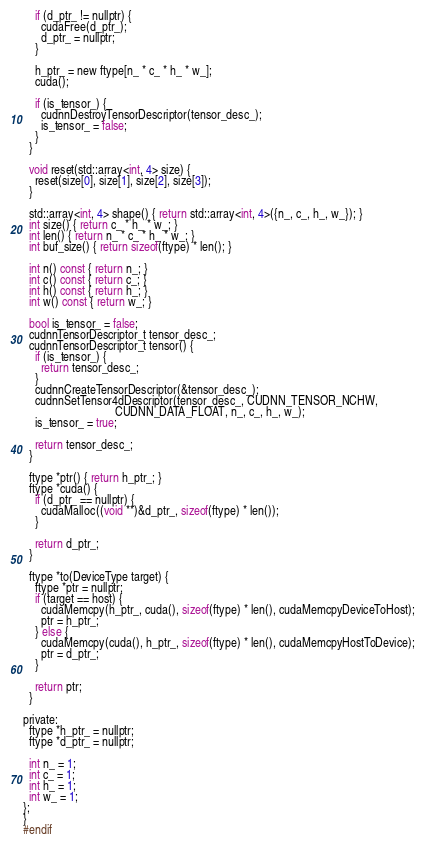Convert code to text. <code><loc_0><loc_0><loc_500><loc_500><_C_>    if (d_ptr_ != nullptr) {
      cudaFree(d_ptr_);
      d_ptr_ = nullptr;
    }

    h_ptr_ = new ftype[n_ * c_ * h_ * w_];
    cuda();

    if (is_tensor_) {
      cudnnDestroyTensorDescriptor(tensor_desc_);
      is_tensor_ = false;
    }
  }

  void reset(std::array<int, 4> size) {
    reset(size[0], size[1], size[2], size[3]);
  }

  std::array<int, 4> shape() { return std::array<int, 4>({n_, c_, h_, w_}); }
  int size() { return c_ * h_ * w_; }
  int len() { return n_ * c_ * h_ * w_; }
  int buf_size() { return sizeof(ftype) * len(); }

  int n() const { return n_; }
  int c() const { return c_; }
  int h() const { return h_; }
  int w() const { return w_; }

  bool is_tensor_ = false;
  cudnnTensorDescriptor_t tensor_desc_;
  cudnnTensorDescriptor_t tensor() {
    if (is_tensor_) {
      return tensor_desc_;
    }
    cudnnCreateTensorDescriptor(&tensor_desc_);
    cudnnSetTensor4dDescriptor(tensor_desc_, CUDNN_TENSOR_NCHW,
                               CUDNN_DATA_FLOAT, n_, c_, h_, w_);
    is_tensor_ = true;

    return tensor_desc_;
  }

  ftype *ptr() { return h_ptr_; }
  ftype *cuda() {
    if (d_ptr_ == nullptr) {
      cudaMalloc((void **)&d_ptr_, sizeof(ftype) * len());
    }

    return d_ptr_;
  }

  ftype *to(DeviceType target) {
    ftype *ptr = nullptr;
    if (target == host) {
      cudaMemcpy(h_ptr_, cuda(), sizeof(ftype) * len(), cudaMemcpyDeviceToHost);
      ptr = h_ptr_;
    } else {
      cudaMemcpy(cuda(), h_ptr_, sizeof(ftype) * len(), cudaMemcpyHostToDevice);
      ptr = d_ptr_;
    }

    return ptr;
  }

private:
  ftype *h_ptr_ = nullptr;
  ftype *d_ptr_ = nullptr;

  int n_ = 1;
  int c_ = 1;
  int h_ = 1;
  int w_ = 1;
};
}
#endif
</code> 